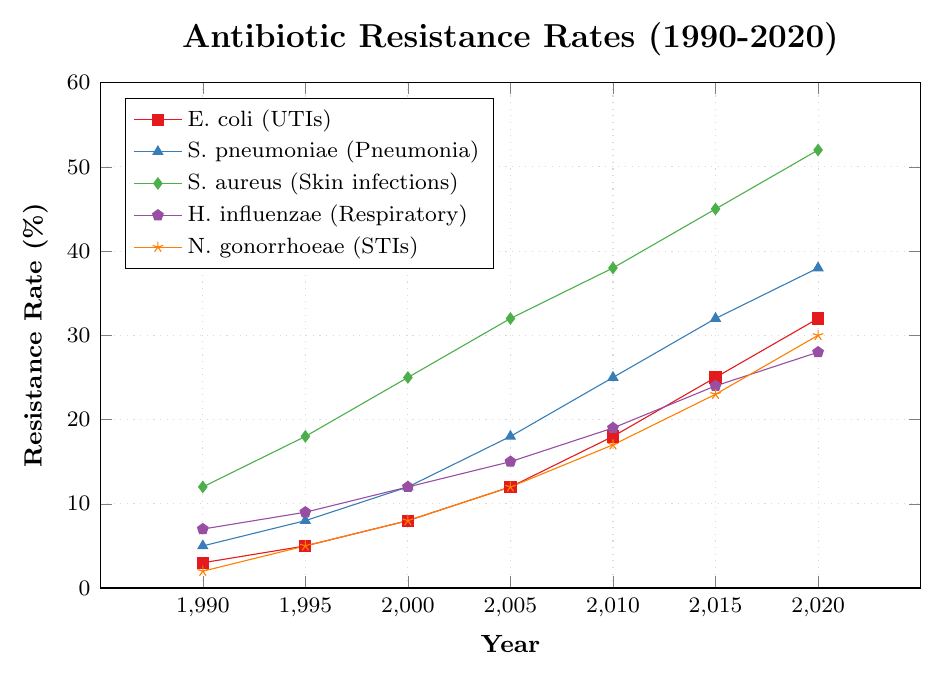what is the resistance rate of E. coli in 2020? Refer to the line marked for E. coli (UTIs) and find where it intersects with the year 2020 on the x-axis. The intersection is at a value of 32% on the y-axis.
Answer: 32% how many years did it take for the resistance rate of S. aureus to increase from 25% to 52%? S. aureus resistance rate was 25% in 2000 and it reached 52% in 2020. It took from 2000 to 2020, which is 20 years.
Answer: 20 years Which bacterial infection had the highest resistance increase between 1990 and 2020? Analyze all lines from the start in 1990 to the end in 2020. S. aureus (Skin infections) increased from 12% to 52%, which is the largest increase of 40%.
Answer: S. aureus Which bacterial infection had almost equal resistance rates in 1995? Compare the rates for all infections in 1995. The resistance rates for S. pneumoniae and N. gonorrhoeae were 8% and 5% respectively.
Answer: None of the infections had almost equal resistance rates What is the average resistance rate of H. influenzae over the three decades? Add the resistance rates for all years for H. influenzae (7+9+12+15+19+24+28) and divide by the number of data points (7). (7+9+12+15+19+24+28)/7 = 16.29%
Answer: 16.29% How much did the resistance rate of N. gonorrhoeae increase from 1995 to 2020? Subtract the resistance rate in 1995 from that in 2020 (30% - 5% = 25%).
Answer: 25% Which bacterial infection had the steepest increase in resistance rate between any two consecutive data points? Observe slope changes between consecutive points, S. aureus had a steep increase from 2010 to 2015 (from 38% to 45%, a 7% increase).
Answer: S. aureus What was the resistance rate of S. pneumoniae in 2005? Refer to the line marked for S. pneumoniae and find where it intersects with the year 2005 on the x-axis, which is at 18% on the y-axis.
Answer: 18% Which two bacterial infections had equal resistance rates in 2000? Check the values for all lines in 2000. E. coli and H. influenzae both had resistance rates of 8% and 12% respectively.
Answer: None of the infections had equal resistance rates Sort the bacterial infections by their resistance rate in 2010 in decreasing order. Read the resistance rates for all infections in 2010 and arrange them. S. aureus (38%), S. pneumoniae (25%), H. influenzae (19%), E. coli (18%), N. gonorrhoeae (17%).
Answer: S. aureus, S. pneumoniae, H. influenzae, E. coli, N. gonorrhoeae 